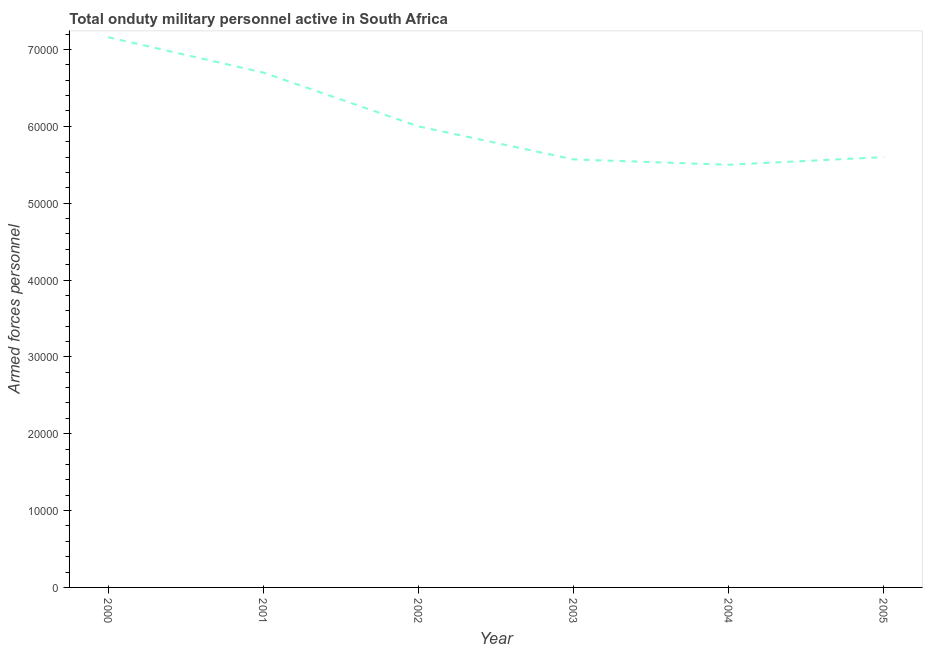What is the number of armed forces personnel in 2004?
Make the answer very short. 5.50e+04. Across all years, what is the maximum number of armed forces personnel?
Provide a succinct answer. 7.16e+04. Across all years, what is the minimum number of armed forces personnel?
Offer a very short reply. 5.50e+04. In which year was the number of armed forces personnel maximum?
Give a very brief answer. 2000. What is the sum of the number of armed forces personnel?
Make the answer very short. 3.65e+05. What is the difference between the number of armed forces personnel in 2003 and 2004?
Provide a short and direct response. 700. What is the average number of armed forces personnel per year?
Your response must be concise. 6.09e+04. What is the median number of armed forces personnel?
Make the answer very short. 5.80e+04. In how many years, is the number of armed forces personnel greater than 4000 ?
Keep it short and to the point. 6. What is the ratio of the number of armed forces personnel in 2000 to that in 2003?
Make the answer very short. 1.29. Is the number of armed forces personnel in 2004 less than that in 2005?
Ensure brevity in your answer.  Yes. What is the difference between the highest and the second highest number of armed forces personnel?
Offer a terse response. 4600. Is the sum of the number of armed forces personnel in 2000 and 2002 greater than the maximum number of armed forces personnel across all years?
Offer a terse response. Yes. What is the difference between the highest and the lowest number of armed forces personnel?
Ensure brevity in your answer.  1.66e+04. In how many years, is the number of armed forces personnel greater than the average number of armed forces personnel taken over all years?
Ensure brevity in your answer.  2. How many lines are there?
Provide a short and direct response. 1. What is the difference between two consecutive major ticks on the Y-axis?
Your response must be concise. 10000. Does the graph contain any zero values?
Your answer should be very brief. No. Does the graph contain grids?
Your answer should be very brief. No. What is the title of the graph?
Keep it short and to the point. Total onduty military personnel active in South Africa. What is the label or title of the Y-axis?
Your response must be concise. Armed forces personnel. What is the Armed forces personnel in 2000?
Provide a succinct answer. 7.16e+04. What is the Armed forces personnel of 2001?
Make the answer very short. 6.70e+04. What is the Armed forces personnel in 2002?
Give a very brief answer. 6.00e+04. What is the Armed forces personnel of 2003?
Give a very brief answer. 5.57e+04. What is the Armed forces personnel in 2004?
Provide a short and direct response. 5.50e+04. What is the Armed forces personnel in 2005?
Your response must be concise. 5.60e+04. What is the difference between the Armed forces personnel in 2000 and 2001?
Give a very brief answer. 4600. What is the difference between the Armed forces personnel in 2000 and 2002?
Offer a very short reply. 1.16e+04. What is the difference between the Armed forces personnel in 2000 and 2003?
Your response must be concise. 1.59e+04. What is the difference between the Armed forces personnel in 2000 and 2004?
Provide a short and direct response. 1.66e+04. What is the difference between the Armed forces personnel in 2000 and 2005?
Give a very brief answer. 1.56e+04. What is the difference between the Armed forces personnel in 2001 and 2002?
Offer a very short reply. 7000. What is the difference between the Armed forces personnel in 2001 and 2003?
Provide a succinct answer. 1.13e+04. What is the difference between the Armed forces personnel in 2001 and 2004?
Make the answer very short. 1.20e+04. What is the difference between the Armed forces personnel in 2001 and 2005?
Provide a short and direct response. 1.10e+04. What is the difference between the Armed forces personnel in 2002 and 2003?
Make the answer very short. 4300. What is the difference between the Armed forces personnel in 2002 and 2004?
Your response must be concise. 5000. What is the difference between the Armed forces personnel in 2002 and 2005?
Your response must be concise. 4000. What is the difference between the Armed forces personnel in 2003 and 2004?
Ensure brevity in your answer.  700. What is the difference between the Armed forces personnel in 2003 and 2005?
Keep it short and to the point. -300. What is the difference between the Armed forces personnel in 2004 and 2005?
Provide a short and direct response. -1000. What is the ratio of the Armed forces personnel in 2000 to that in 2001?
Your answer should be compact. 1.07. What is the ratio of the Armed forces personnel in 2000 to that in 2002?
Keep it short and to the point. 1.19. What is the ratio of the Armed forces personnel in 2000 to that in 2003?
Give a very brief answer. 1.28. What is the ratio of the Armed forces personnel in 2000 to that in 2004?
Your answer should be compact. 1.3. What is the ratio of the Armed forces personnel in 2000 to that in 2005?
Ensure brevity in your answer.  1.28. What is the ratio of the Armed forces personnel in 2001 to that in 2002?
Your answer should be compact. 1.12. What is the ratio of the Armed forces personnel in 2001 to that in 2003?
Offer a terse response. 1.2. What is the ratio of the Armed forces personnel in 2001 to that in 2004?
Ensure brevity in your answer.  1.22. What is the ratio of the Armed forces personnel in 2001 to that in 2005?
Offer a very short reply. 1.2. What is the ratio of the Armed forces personnel in 2002 to that in 2003?
Make the answer very short. 1.08. What is the ratio of the Armed forces personnel in 2002 to that in 2004?
Offer a terse response. 1.09. What is the ratio of the Armed forces personnel in 2002 to that in 2005?
Your answer should be compact. 1.07. What is the ratio of the Armed forces personnel in 2003 to that in 2004?
Offer a very short reply. 1.01. What is the ratio of the Armed forces personnel in 2004 to that in 2005?
Offer a very short reply. 0.98. 